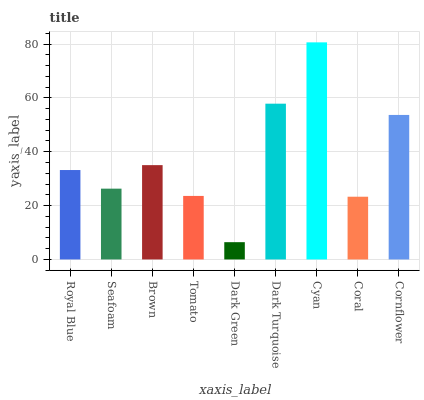Is Dark Green the minimum?
Answer yes or no. Yes. Is Cyan the maximum?
Answer yes or no. Yes. Is Seafoam the minimum?
Answer yes or no. No. Is Seafoam the maximum?
Answer yes or no. No. Is Royal Blue greater than Seafoam?
Answer yes or no. Yes. Is Seafoam less than Royal Blue?
Answer yes or no. Yes. Is Seafoam greater than Royal Blue?
Answer yes or no. No. Is Royal Blue less than Seafoam?
Answer yes or no. No. Is Royal Blue the high median?
Answer yes or no. Yes. Is Royal Blue the low median?
Answer yes or no. Yes. Is Coral the high median?
Answer yes or no. No. Is Dark Green the low median?
Answer yes or no. No. 